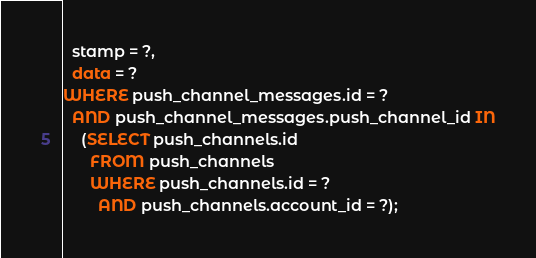<code> <loc_0><loc_0><loc_500><loc_500><_SQL_>  stamp = ?,
  data = ?
WHERE push_channel_messages.id = ?
  AND push_channel_messages.push_channel_id IN
    (SELECT push_channels.id
      FROM push_channels
      WHERE push_channels.id = ?
        AND push_channels.account_id = ?);
</code> 